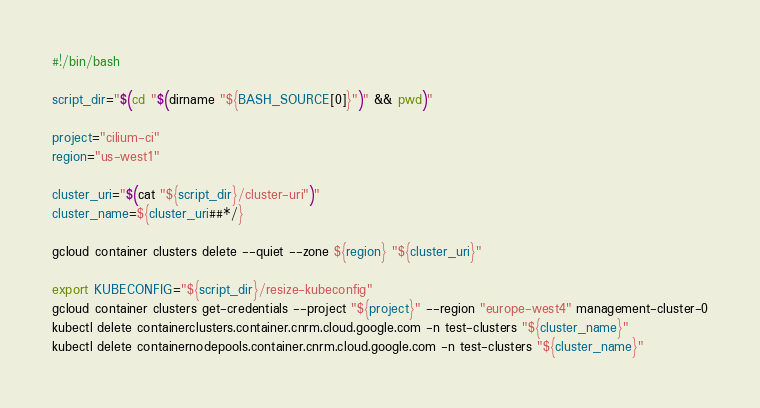Convert code to text. <code><loc_0><loc_0><loc_500><loc_500><_Bash_>#!/bin/bash

script_dir="$(cd "$(dirname "${BASH_SOURCE[0]}")" && pwd)"

project="cilium-ci"
region="us-west1"

cluster_uri="$(cat "${script_dir}/cluster-uri")"
cluster_name=${cluster_uri##*/}

gcloud container clusters delete --quiet --zone ${region} "${cluster_uri}"

export KUBECONFIG="${script_dir}/resize-kubeconfig"
gcloud container clusters get-credentials --project "${project}" --region "europe-west4" management-cluster-0
kubectl delete containerclusters.container.cnrm.cloud.google.com -n test-clusters "${cluster_name}"
kubectl delete containernodepools.container.cnrm.cloud.google.com -n test-clusters "${cluster_name}"
</code> 